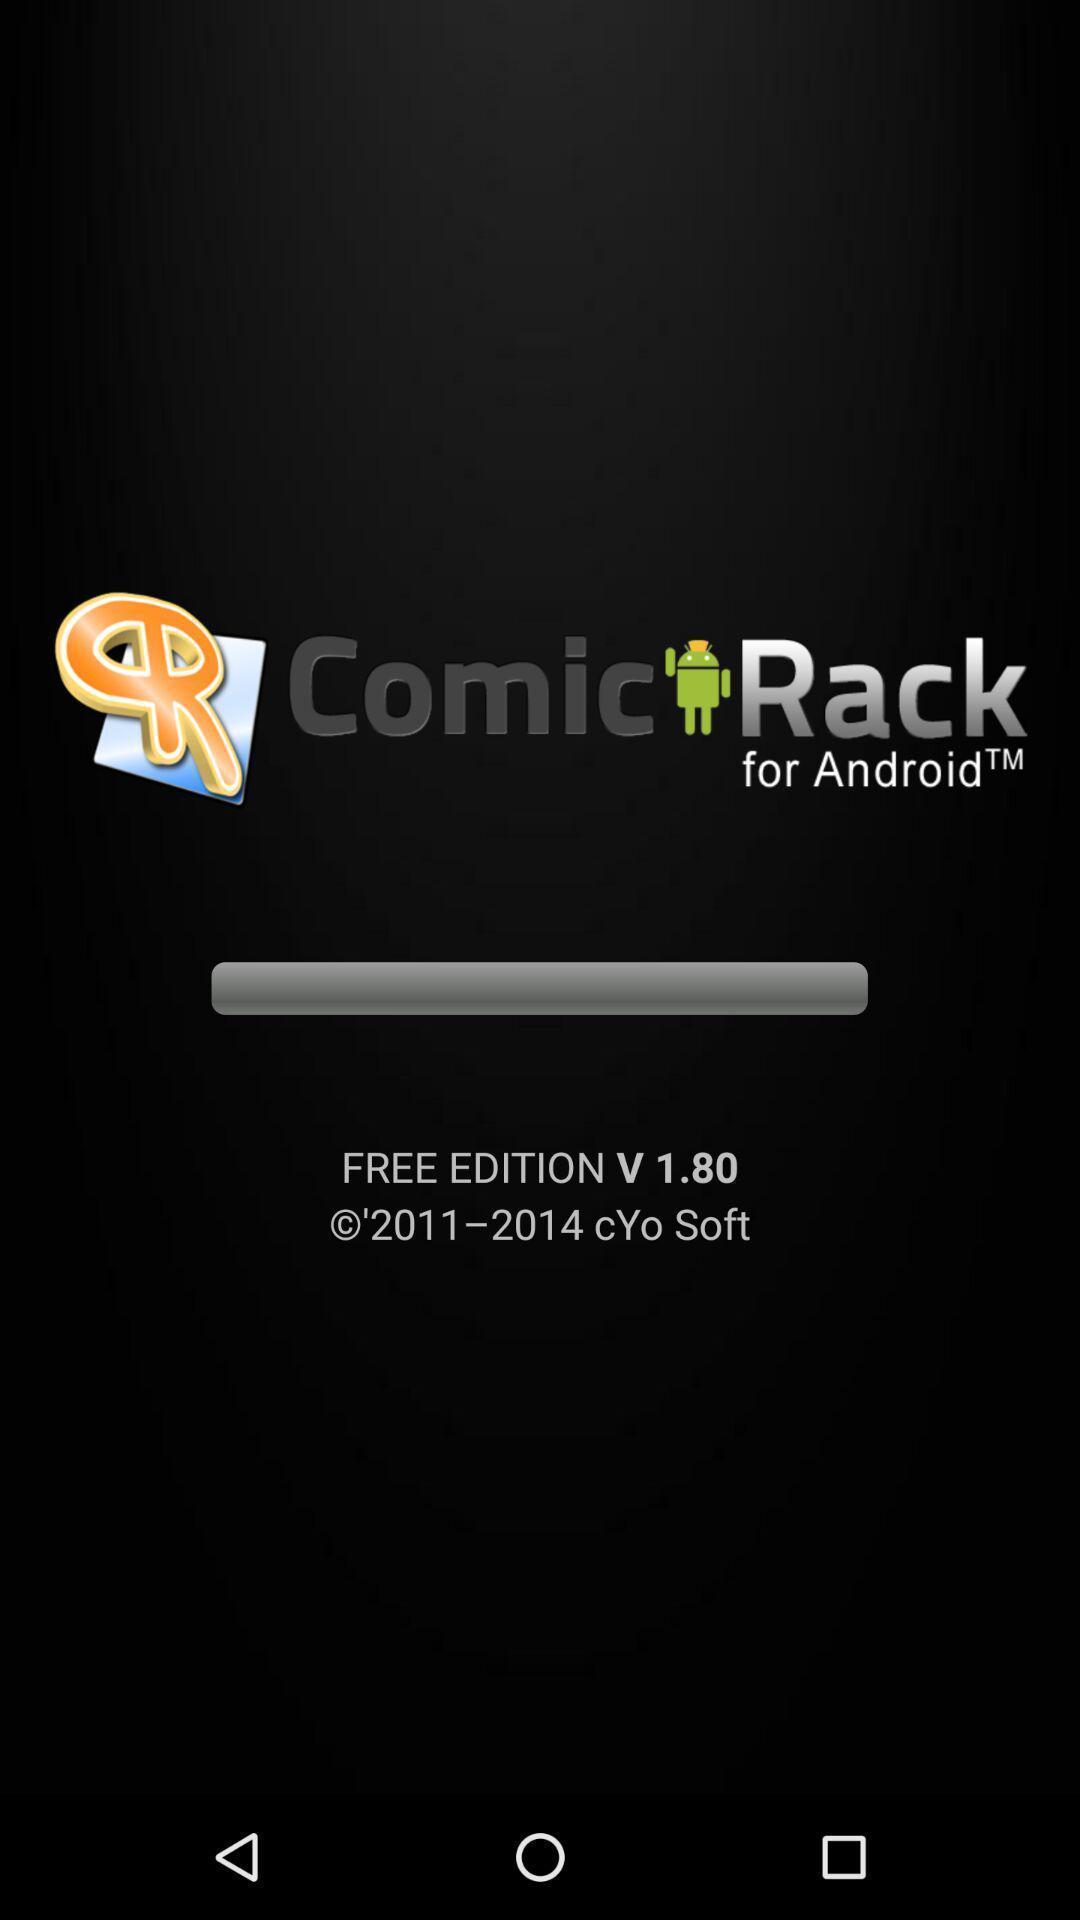What is the overall content of this screenshot? Page showing information about application. 